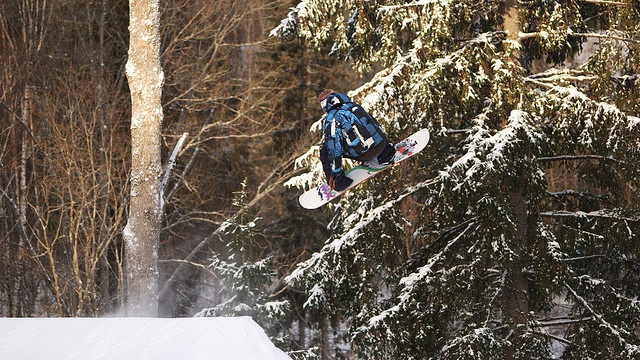Describe the objects in this image and their specific colors. I can see people in maroon, black, gray, blue, and navy tones and snowboard in maroon, lightgray, darkgray, gray, and black tones in this image. 